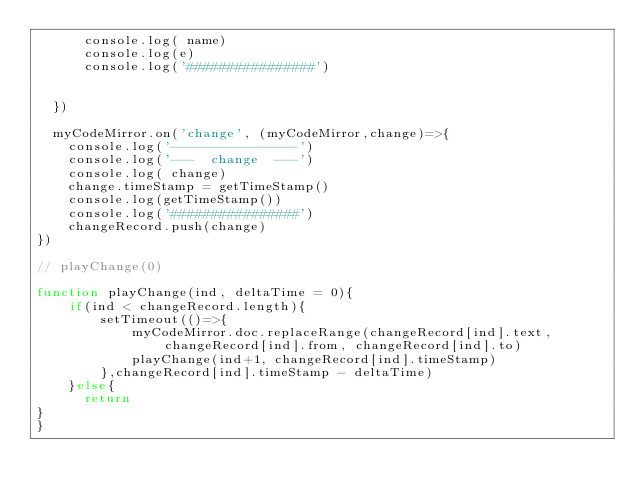<code> <loc_0><loc_0><loc_500><loc_500><_JavaScript_>      console.log( name)
      console.log(e)
      console.log('################')


  })

  myCodeMirror.on('change', (myCodeMirror,change)=>{
    console.log('----------------')
    console.log('---  change  ---')
    console.log( change)
    change.timeStamp = getTimeStamp()
    console.log(getTimeStamp())
    console.log('################')
    changeRecord.push(change)
})

// playChange(0)

function playChange(ind, deltaTime = 0){
    if(ind < changeRecord.length){
        setTimeout(()=>{
            myCodeMirror.doc.replaceRange(changeRecord[ind].text, changeRecord[ind].from, changeRecord[ind].to)
            playChange(ind+1, changeRecord[ind].timeStamp)
        },changeRecord[ind].timeStamp - deltaTime)
    }else{
      return
}
}</code> 